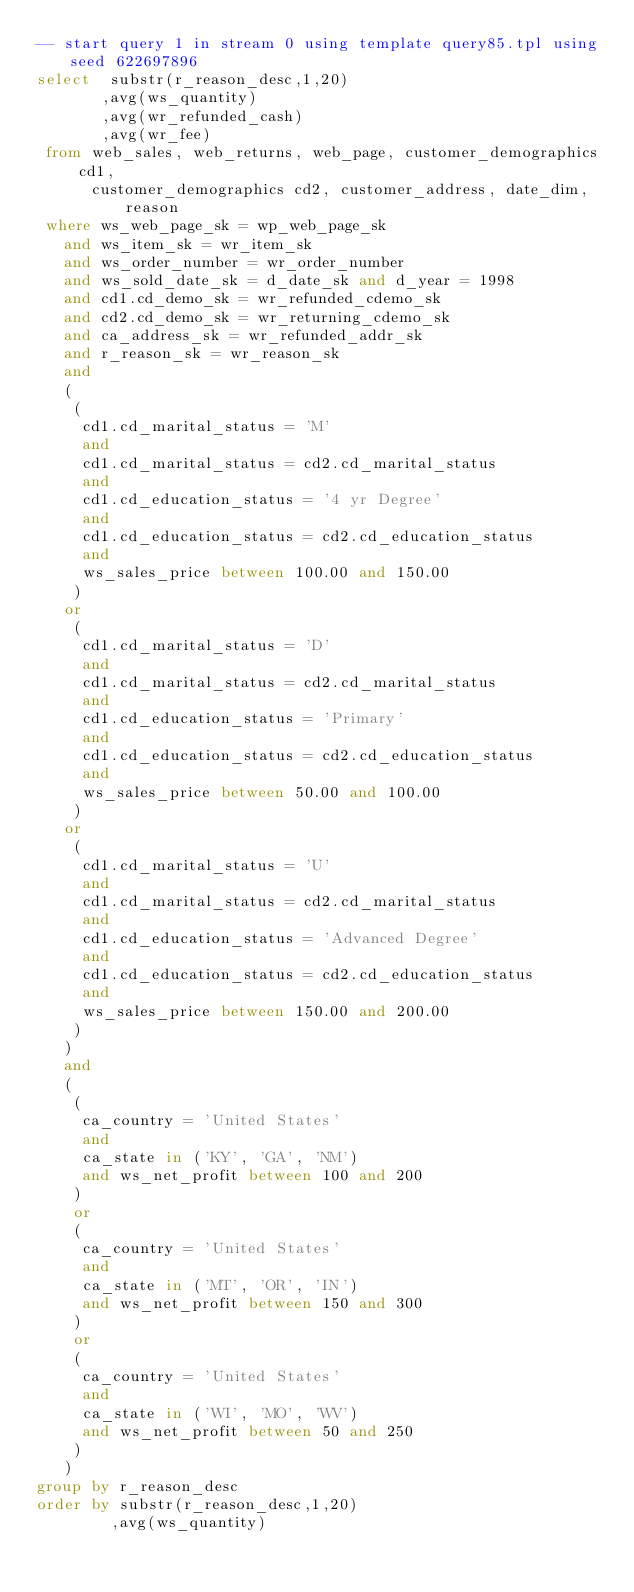<code> <loc_0><loc_0><loc_500><loc_500><_SQL_>-- start query 1 in stream 0 using template query85.tpl using seed 622697896
select  substr(r_reason_desc,1,20)
       ,avg(ws_quantity)
       ,avg(wr_refunded_cash)
       ,avg(wr_fee)
 from web_sales, web_returns, web_page, customer_demographics cd1,
      customer_demographics cd2, customer_address, date_dim, reason 
 where ws_web_page_sk = wp_web_page_sk
   and ws_item_sk = wr_item_sk
   and ws_order_number = wr_order_number
   and ws_sold_date_sk = d_date_sk and d_year = 1998
   and cd1.cd_demo_sk = wr_refunded_cdemo_sk 
   and cd2.cd_demo_sk = wr_returning_cdemo_sk
   and ca_address_sk = wr_refunded_addr_sk
   and r_reason_sk = wr_reason_sk
   and
   (
    (
     cd1.cd_marital_status = 'M'
     and
     cd1.cd_marital_status = cd2.cd_marital_status
     and
     cd1.cd_education_status = '4 yr Degree'
     and 
     cd1.cd_education_status = cd2.cd_education_status
     and
     ws_sales_price between 100.00 and 150.00
    )
   or
    (
     cd1.cd_marital_status = 'D'
     and
     cd1.cd_marital_status = cd2.cd_marital_status
     and
     cd1.cd_education_status = 'Primary' 
     and
     cd1.cd_education_status = cd2.cd_education_status
     and
     ws_sales_price between 50.00 and 100.00
    )
   or
    (
     cd1.cd_marital_status = 'U'
     and
     cd1.cd_marital_status = cd2.cd_marital_status
     and
     cd1.cd_education_status = 'Advanced Degree'
     and
     cd1.cd_education_status = cd2.cd_education_status
     and
     ws_sales_price between 150.00 and 200.00
    )
   )
   and
   (
    (
     ca_country = 'United States'
     and
     ca_state in ('KY', 'GA', 'NM')
     and ws_net_profit between 100 and 200  
    )
    or
    (
     ca_country = 'United States'
     and
     ca_state in ('MT', 'OR', 'IN')
     and ws_net_profit between 150 and 300  
    )
    or
    (
     ca_country = 'United States'
     and
     ca_state in ('WI', 'MO', 'WV')
     and ws_net_profit between 50 and 250  
    )
   )
group by r_reason_desc
order by substr(r_reason_desc,1,20)
        ,avg(ws_quantity)</code> 